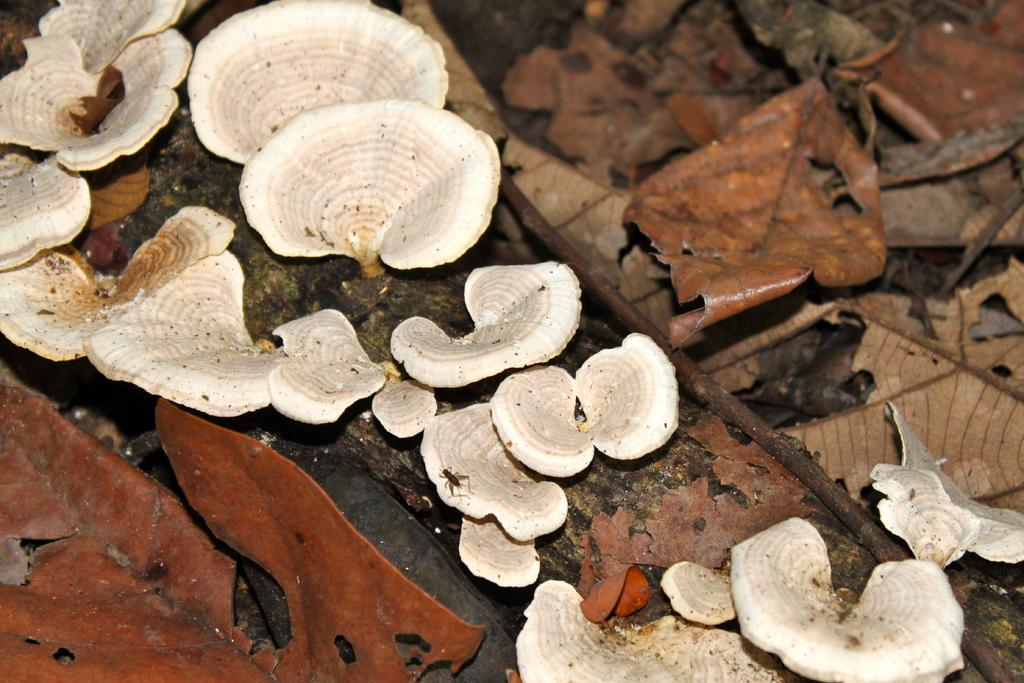What type of fungi can be seen in the image? There are mushrooms in the image. What type of plant material is present in the image? There are leaves in the image. What type of metal is being used to create a zinc rainstorm in the image? There is no metal, zinc, or rainstorm present in the image; it features mushrooms and leaves. 